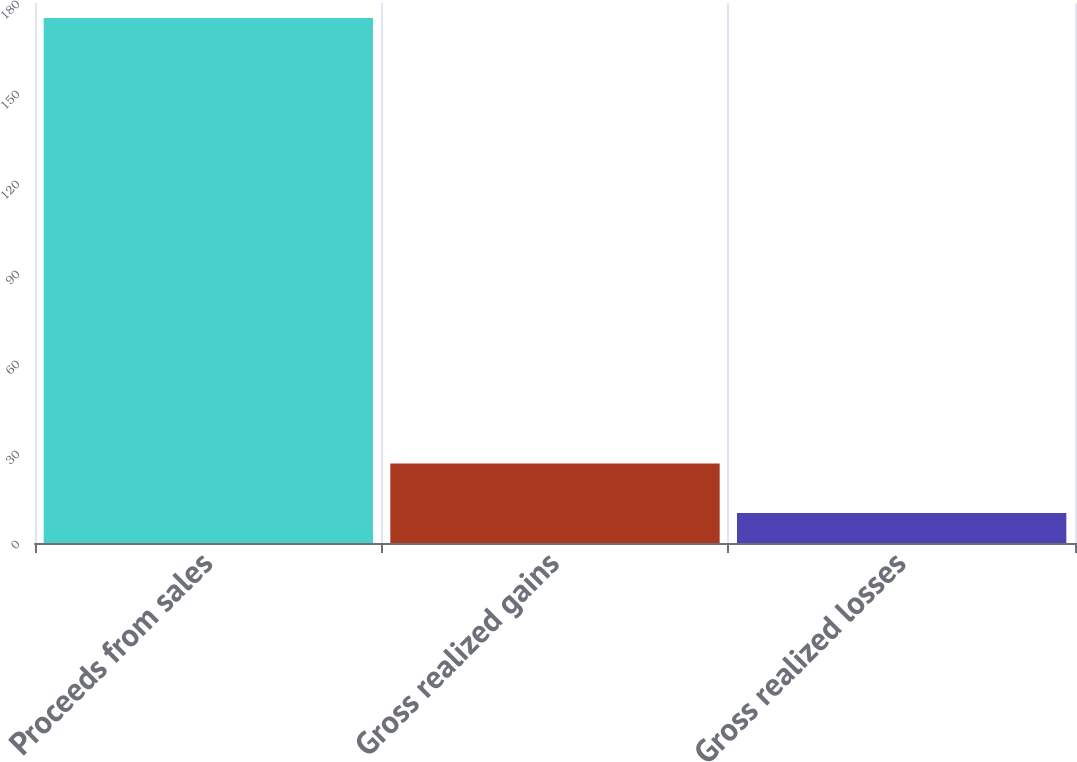<chart> <loc_0><loc_0><loc_500><loc_500><bar_chart><fcel>Proceeds from sales<fcel>Gross realized gains<fcel>Gross realized losses<nl><fcel>175<fcel>26.5<fcel>10<nl></chart> 